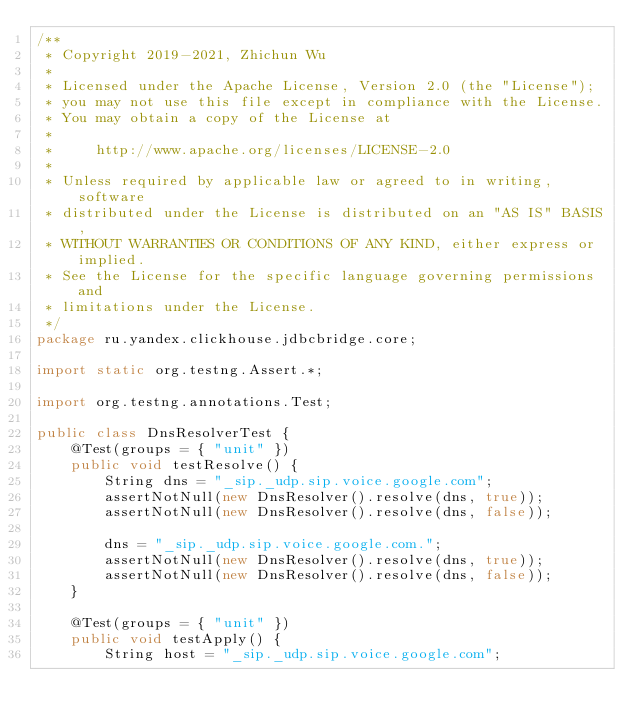<code> <loc_0><loc_0><loc_500><loc_500><_Java_>/**
 * Copyright 2019-2021, Zhichun Wu
 *
 * Licensed under the Apache License, Version 2.0 (the "License");
 * you may not use this file except in compliance with the License.
 * You may obtain a copy of the License at
 *
 *     http://www.apache.org/licenses/LICENSE-2.0
 *
 * Unless required by applicable law or agreed to in writing, software
 * distributed under the License is distributed on an "AS IS" BASIS,
 * WITHOUT WARRANTIES OR CONDITIONS OF ANY KIND, either express or implied.
 * See the License for the specific language governing permissions and
 * limitations under the License.
 */
package ru.yandex.clickhouse.jdbcbridge.core;

import static org.testng.Assert.*;

import org.testng.annotations.Test;

public class DnsResolverTest {
    @Test(groups = { "unit" })
    public void testResolve() {
        String dns = "_sip._udp.sip.voice.google.com";
        assertNotNull(new DnsResolver().resolve(dns, true));
        assertNotNull(new DnsResolver().resolve(dns, false));

        dns = "_sip._udp.sip.voice.google.com.";
        assertNotNull(new DnsResolver().resolve(dns, true));
        assertNotNull(new DnsResolver().resolve(dns, false));
    }

    @Test(groups = { "unit" })
    public void testApply() {
        String host = "_sip._udp.sip.voice.google.com";</code> 